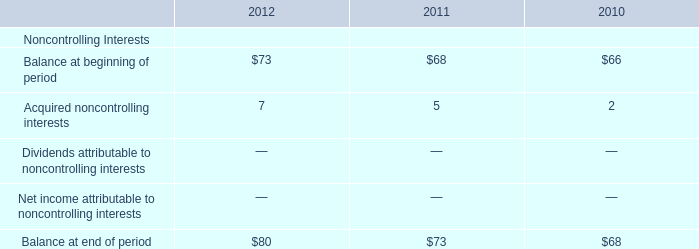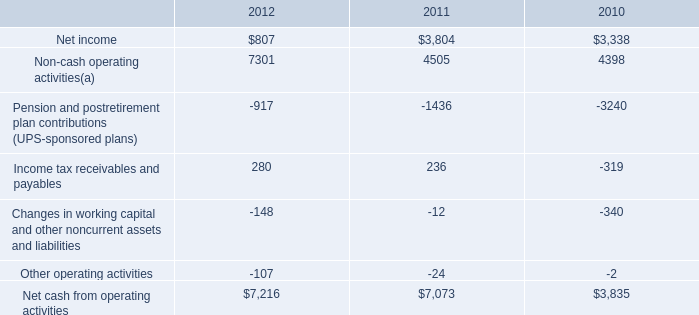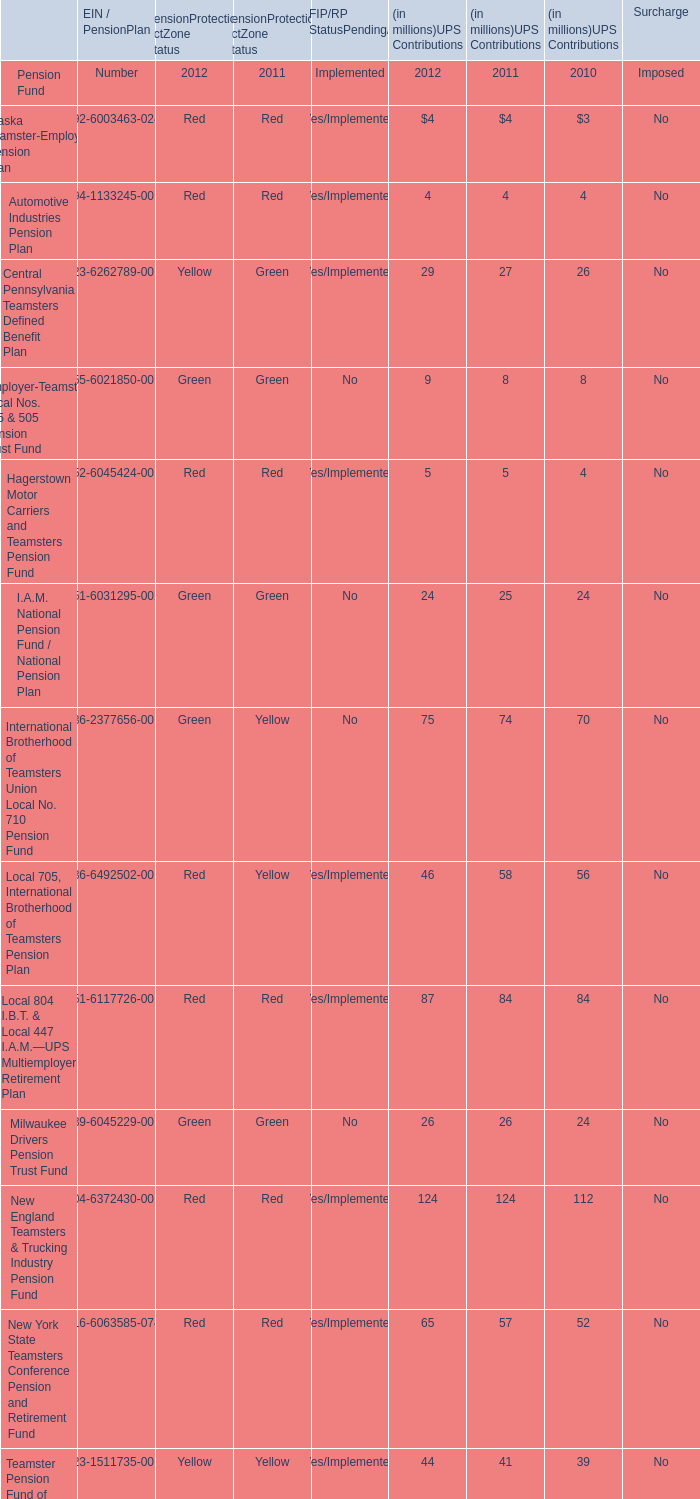what was the percentage change in net cash from operating activities from 2010 to 2011? 
Computations: ((7073 - 3835) / 3835)
Answer: 0.84433. 